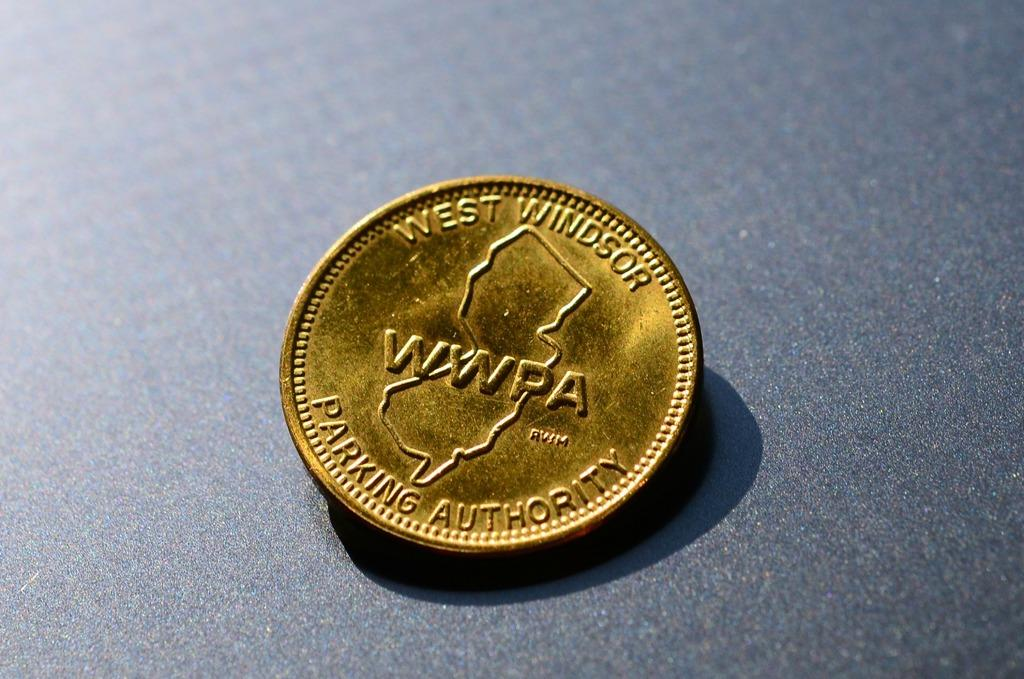<image>
Write a terse but informative summary of the picture. a gold coin that says 'west windor parking authority' on it 